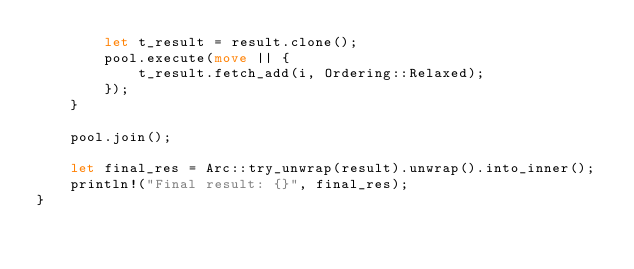<code> <loc_0><loc_0><loc_500><loc_500><_Rust_>        let t_result = result.clone();
        pool.execute(move || {
            t_result.fetch_add(i, Ordering::Relaxed);
        });
    }

    pool.join();

    let final_res = Arc::try_unwrap(result).unwrap().into_inner();
    println!("Final result: {}", final_res);
}
</code> 